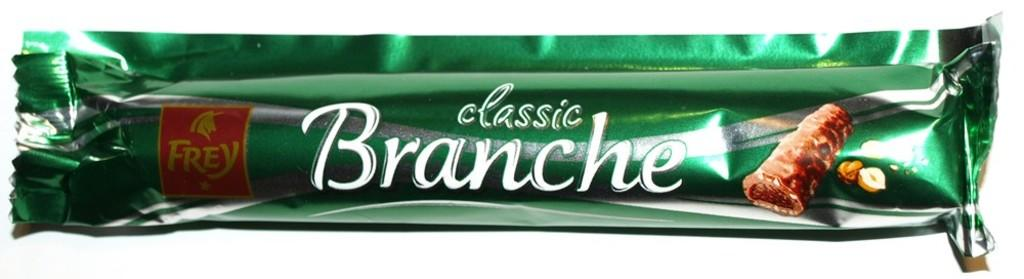<image>
Present a compact description of the photo's key features. A bar of food called classic Branche in a green wrapper 